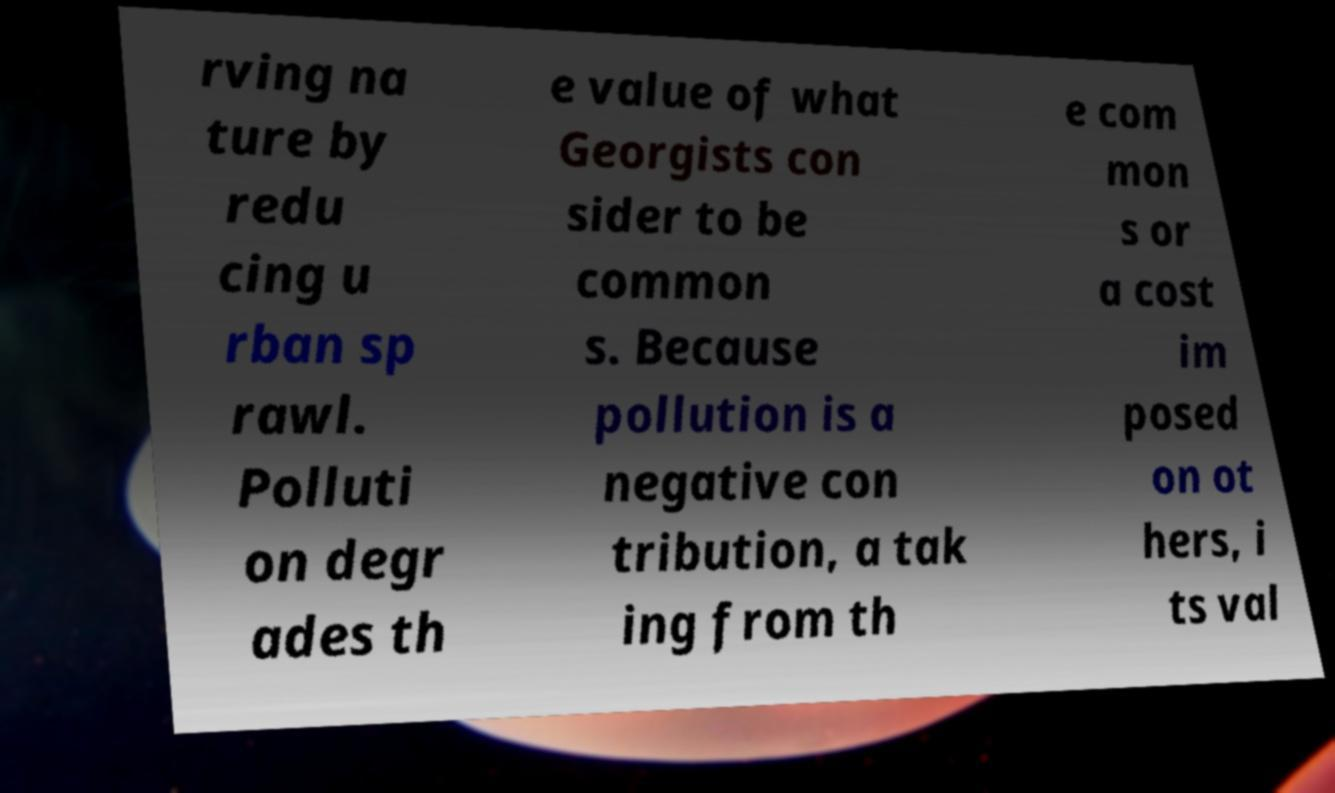Can you read and provide the text displayed in the image?This photo seems to have some interesting text. Can you extract and type it out for me? rving na ture by redu cing u rban sp rawl. Polluti on degr ades th e value of what Georgists con sider to be common s. Because pollution is a negative con tribution, a tak ing from th e com mon s or a cost im posed on ot hers, i ts val 